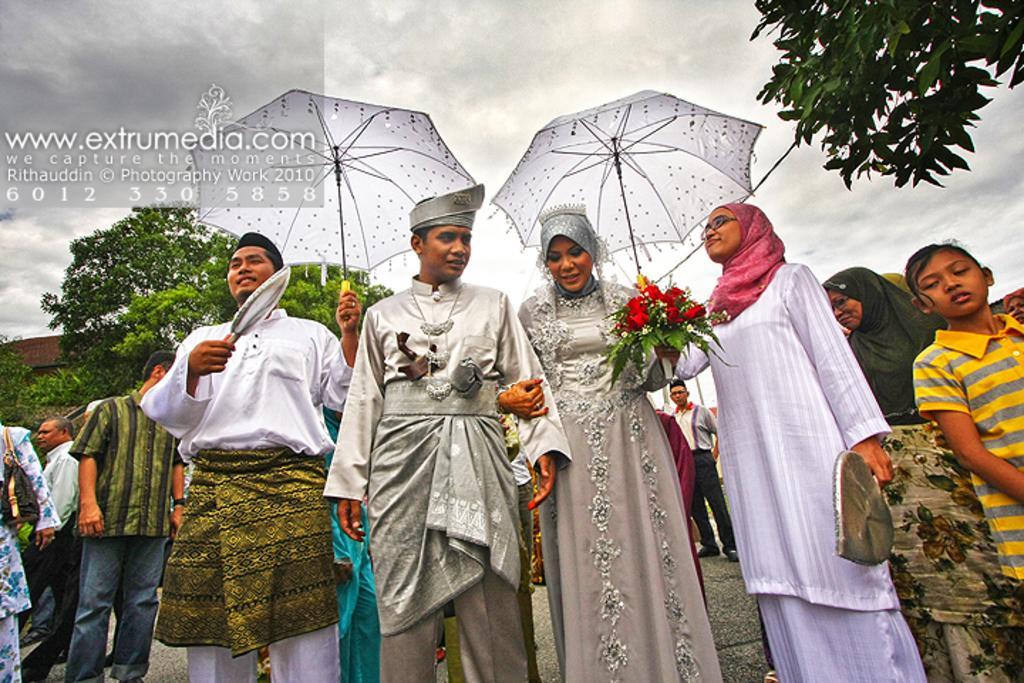How would you summarize this image in a sentence or two? Here in this picture we can see a group o f men and women standing over a place and we can see two persons are holding umbrellas in their hands an behind them we can see plants and trees present all over there and we can also see clouds in sky. 